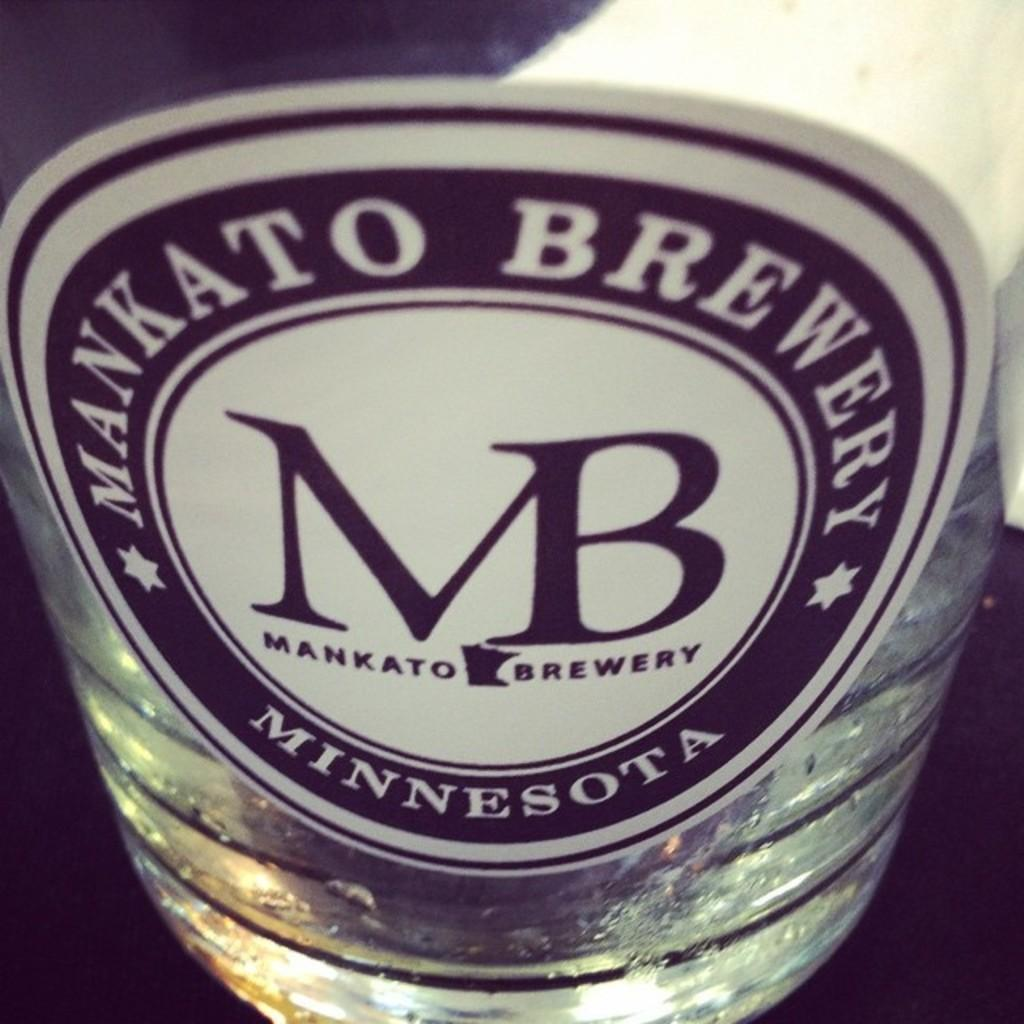<image>
Write a terse but informative summary of the picture. A beer glass from Mankato Brewery in Minnesota. 